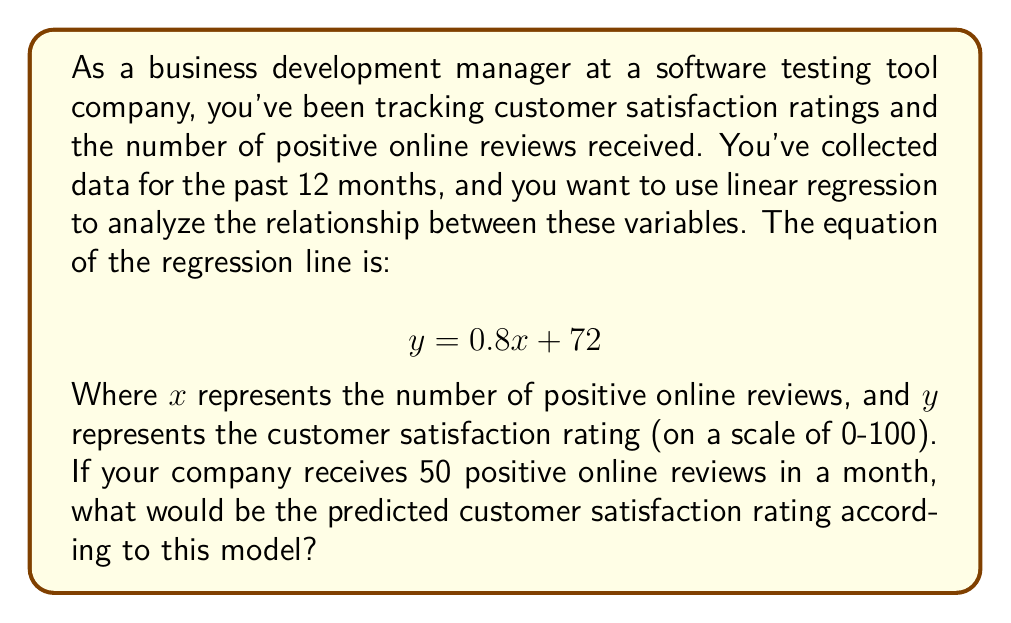Solve this math problem. To solve this problem, we need to use the given linear regression equation and substitute the known value for $x$. Let's break it down step-by-step:

1. The linear regression equation is given as:
   $$ y = 0.8x + 72 $$

2. We're told that $x$ represents the number of positive online reviews, and we want to find the predicted customer satisfaction rating ($y$) when $x = 50$.

3. Let's substitute $x = 50$ into the equation:
   $$ y = 0.8(50) + 72 $$

4. Now, let's solve the equation:
   $$ y = 40 + 72 $$
   $$ y = 112 $$

5. However, we need to consider that customer satisfaction ratings are typically on a scale of 0-100. Since our result exceeds 100, we should cap it at 100.

Therefore, the predicted customer satisfaction rating when there are 50 positive online reviews is 100.
Answer: 100 